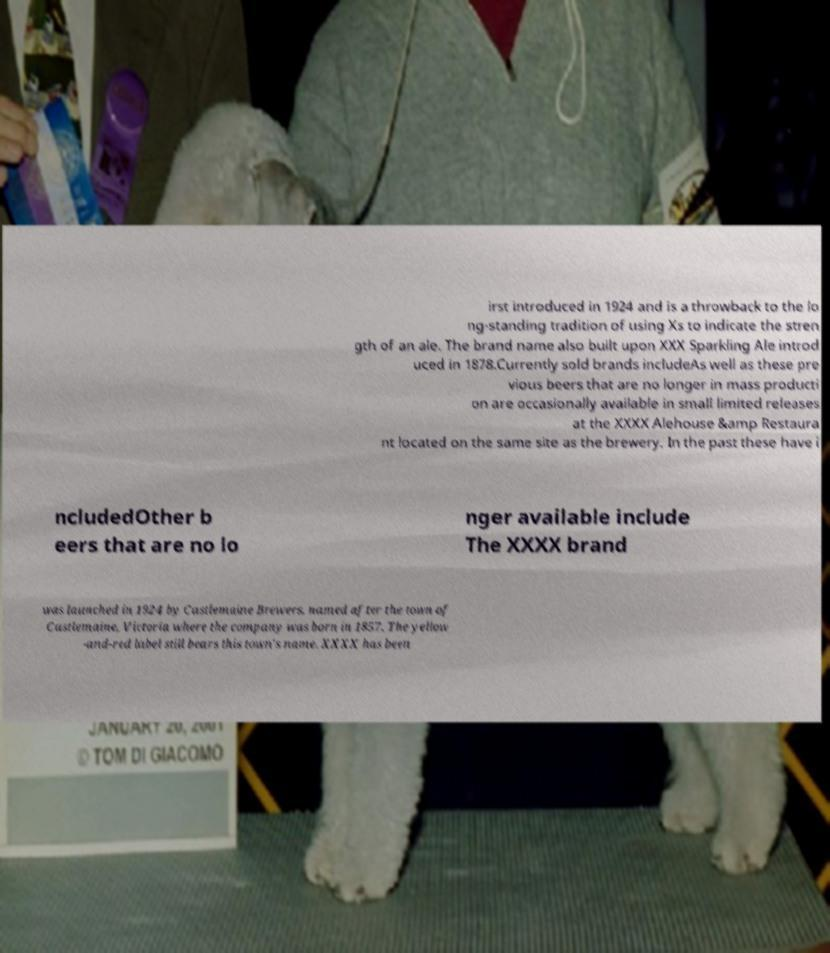Can you read and provide the text displayed in the image?This photo seems to have some interesting text. Can you extract and type it out for me? irst introduced in 1924 and is a throwback to the lo ng-standing tradition of using Xs to indicate the stren gth of an ale. The brand name also built upon XXX Sparkling Ale introd uced in 1878.Currently sold brands includeAs well as these pre vious beers that are no longer in mass producti on are occasionally available in small limited releases at the XXXX Alehouse &amp Restaura nt located on the same site as the brewery. In the past these have i ncludedOther b eers that are no lo nger available include The XXXX brand was launched in 1924 by Castlemaine Brewers, named after the town of Castlemaine, Victoria where the company was born in 1857. The yellow -and-red label still bears this town's name. XXXX has been 